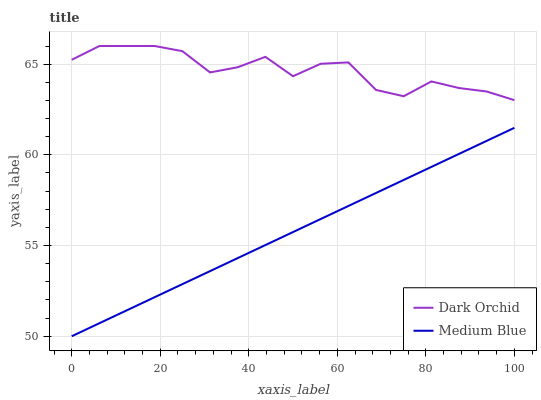Does Medium Blue have the minimum area under the curve?
Answer yes or no. Yes. Does Dark Orchid have the maximum area under the curve?
Answer yes or no. Yes. Does Dark Orchid have the minimum area under the curve?
Answer yes or no. No. Is Medium Blue the smoothest?
Answer yes or no. Yes. Is Dark Orchid the roughest?
Answer yes or no. Yes. Is Dark Orchid the smoothest?
Answer yes or no. No. Does Medium Blue have the lowest value?
Answer yes or no. Yes. Does Dark Orchid have the lowest value?
Answer yes or no. No. Does Dark Orchid have the highest value?
Answer yes or no. Yes. Is Medium Blue less than Dark Orchid?
Answer yes or no. Yes. Is Dark Orchid greater than Medium Blue?
Answer yes or no. Yes. Does Medium Blue intersect Dark Orchid?
Answer yes or no. No. 